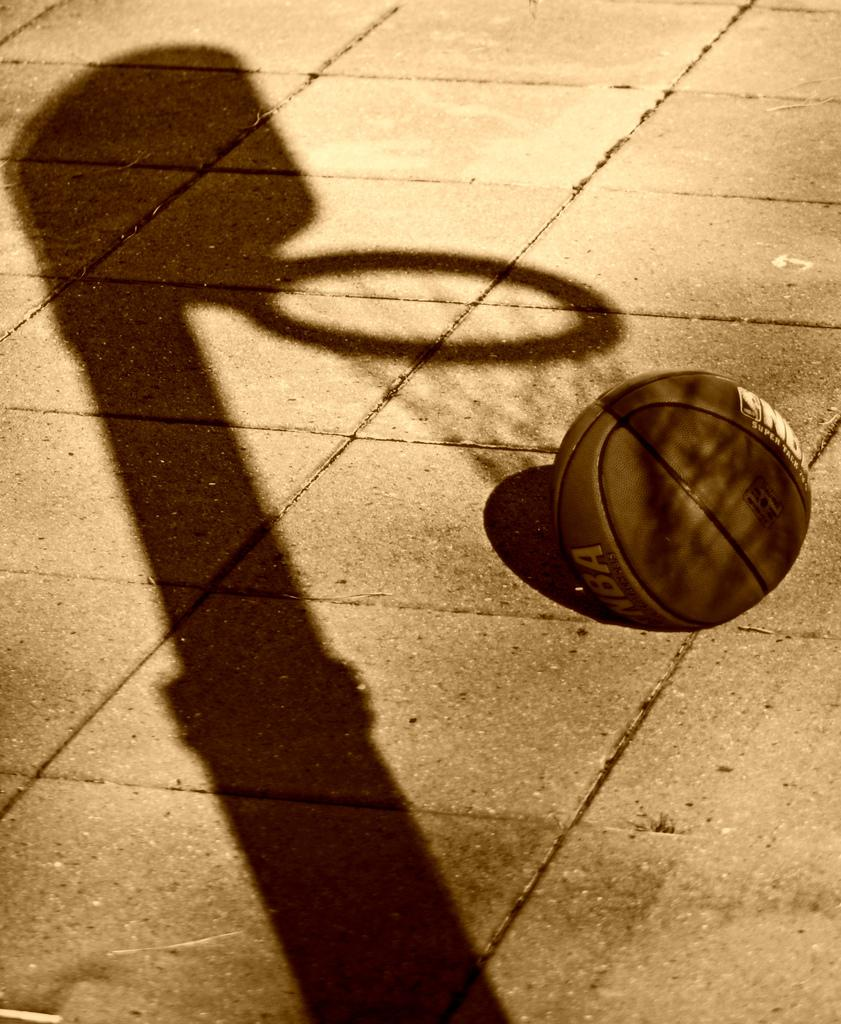What object is on the ground in the image? There is a ball on the ground in the image. What can be seen in the image that is not physically present? There is a reflection of a pole and a net in the image. What time of day is it in the bedroom, as depicted in the image? There is no bedroom present in the image, and therefore no indication of the time of day. 